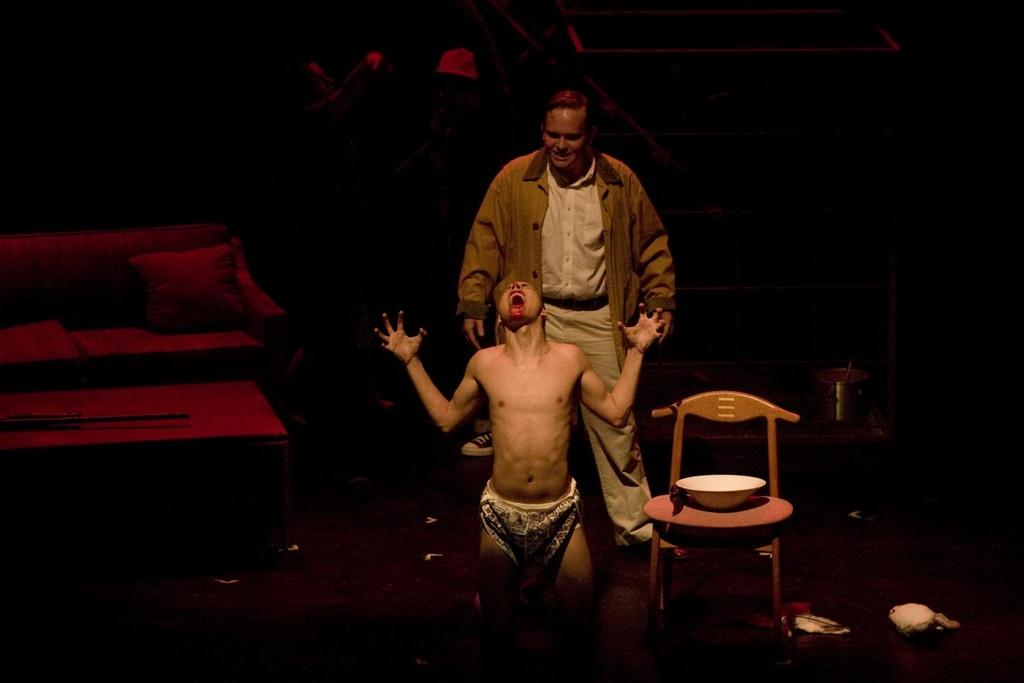How many people are in the image? There are two persons in the image. What type of furniture is present in the image? There is a chair, a sofa, and a table in the image. What object can be seen on the table? There is a bowl on the table in the image. What type of nut is being used to oil the chair in the image? There is no nut or oil present in the image, and the chair does not appear to be in need of oiling. 